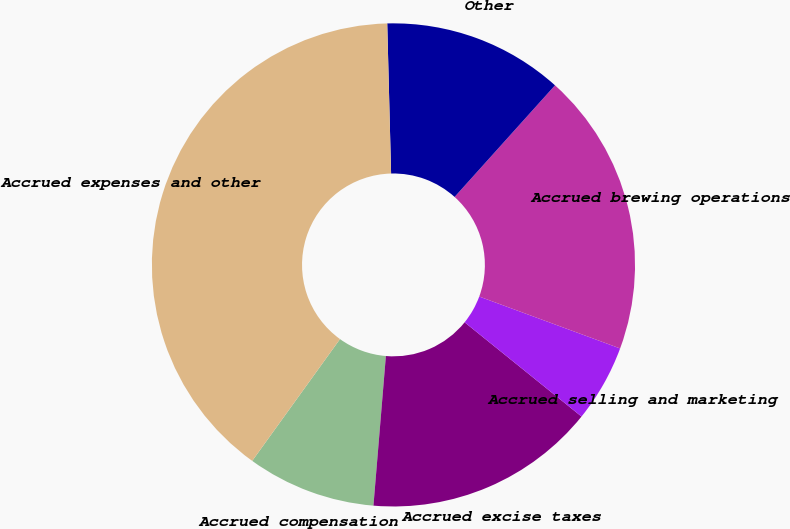<chart> <loc_0><loc_0><loc_500><loc_500><pie_chart><fcel>Accrued compensation<fcel>Accrued excise taxes<fcel>Accrued selling and marketing<fcel>Accrued brewing operations<fcel>Other<fcel>Accrued expenses and other<nl><fcel>8.62%<fcel>15.52%<fcel>5.18%<fcel>18.96%<fcel>12.07%<fcel>39.65%<nl></chart> 